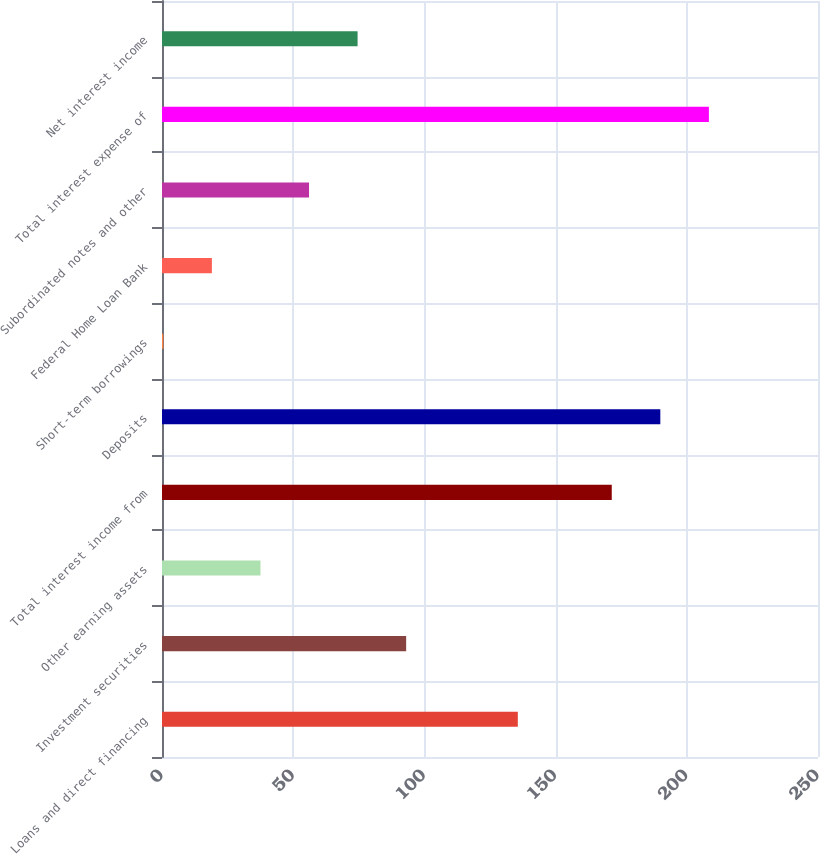<chart> <loc_0><loc_0><loc_500><loc_500><bar_chart><fcel>Loans and direct financing<fcel>Investment securities<fcel>Other earning assets<fcel>Total interest income from<fcel>Deposits<fcel>Short-term borrowings<fcel>Federal Home Loan Bank<fcel>Subordinated notes and other<fcel>Total interest expense of<fcel>Net interest income<nl><fcel>135.6<fcel>93.05<fcel>37.52<fcel>171.4<fcel>189.91<fcel>0.5<fcel>19.01<fcel>56.03<fcel>208.42<fcel>74.54<nl></chart> 